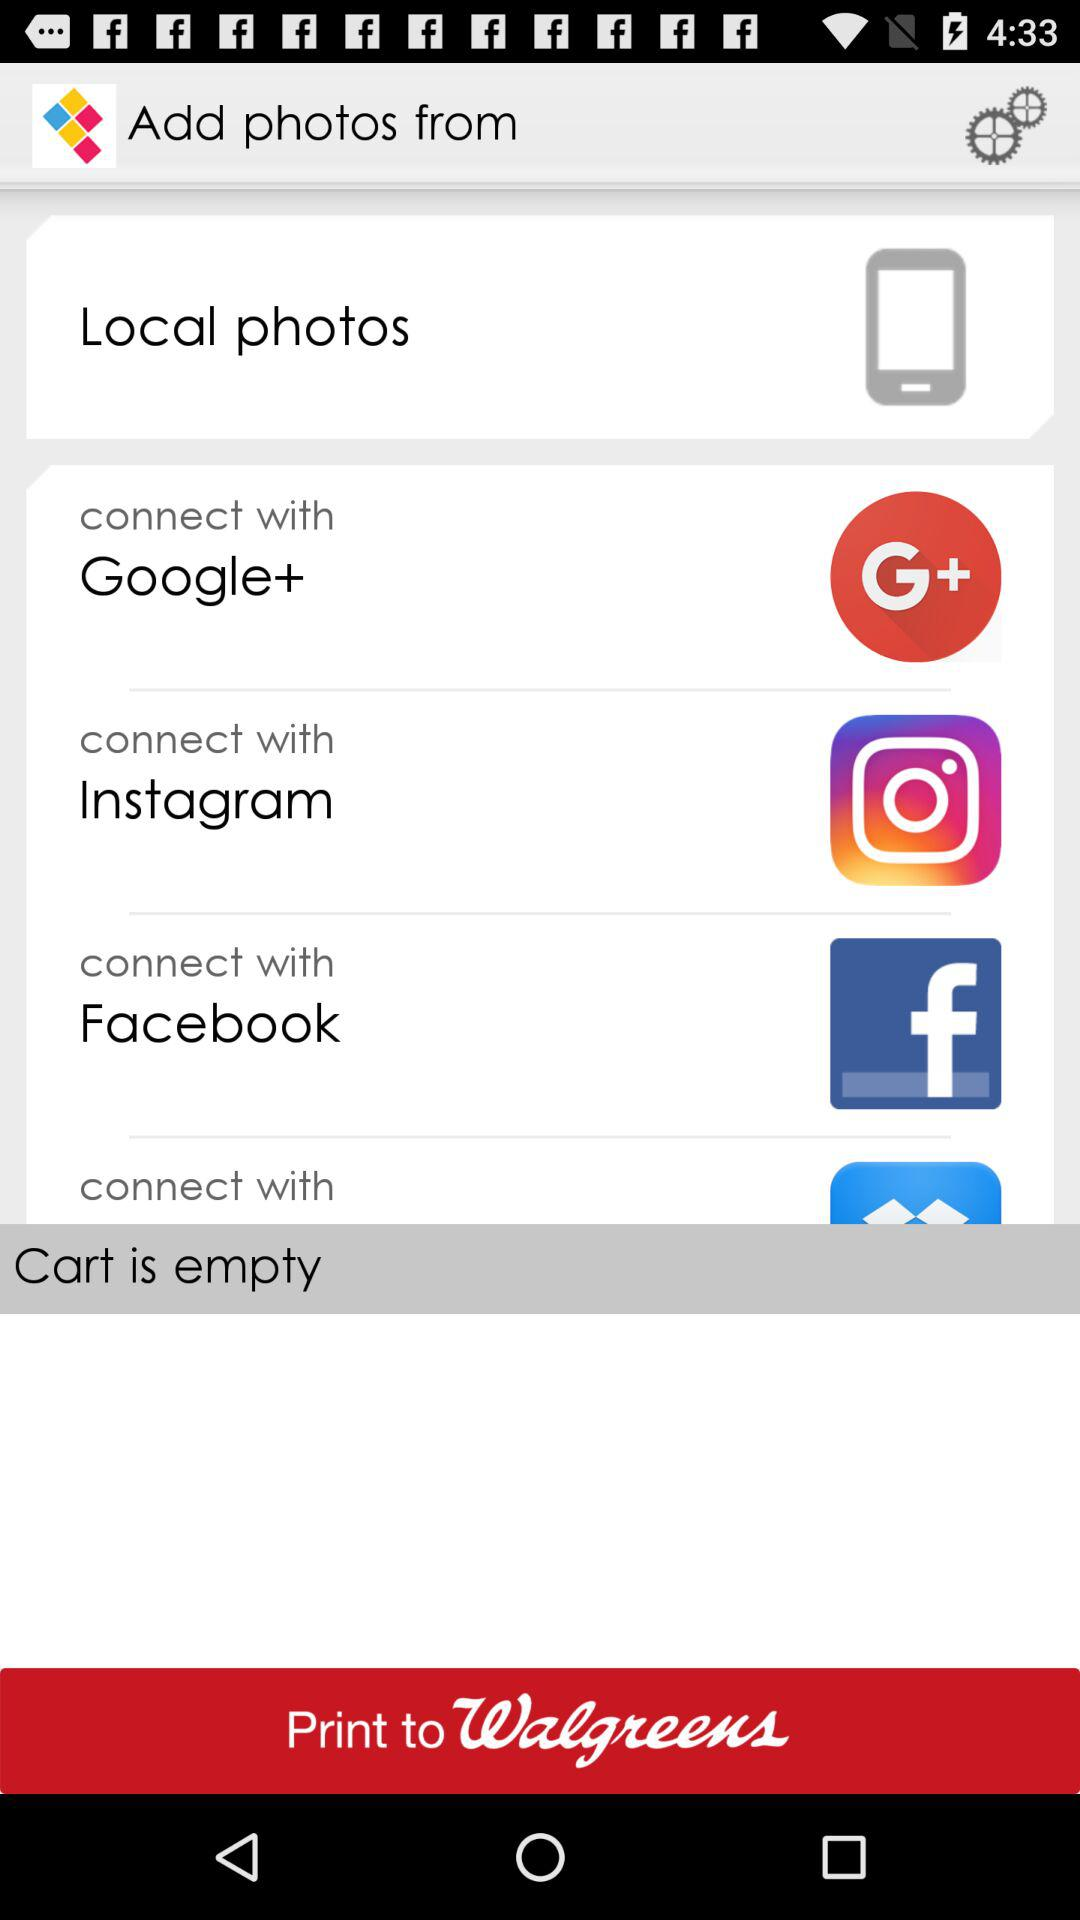What are the different options through which we can connect? You can connect with "Google+", "Instagram" and "Facebook". 